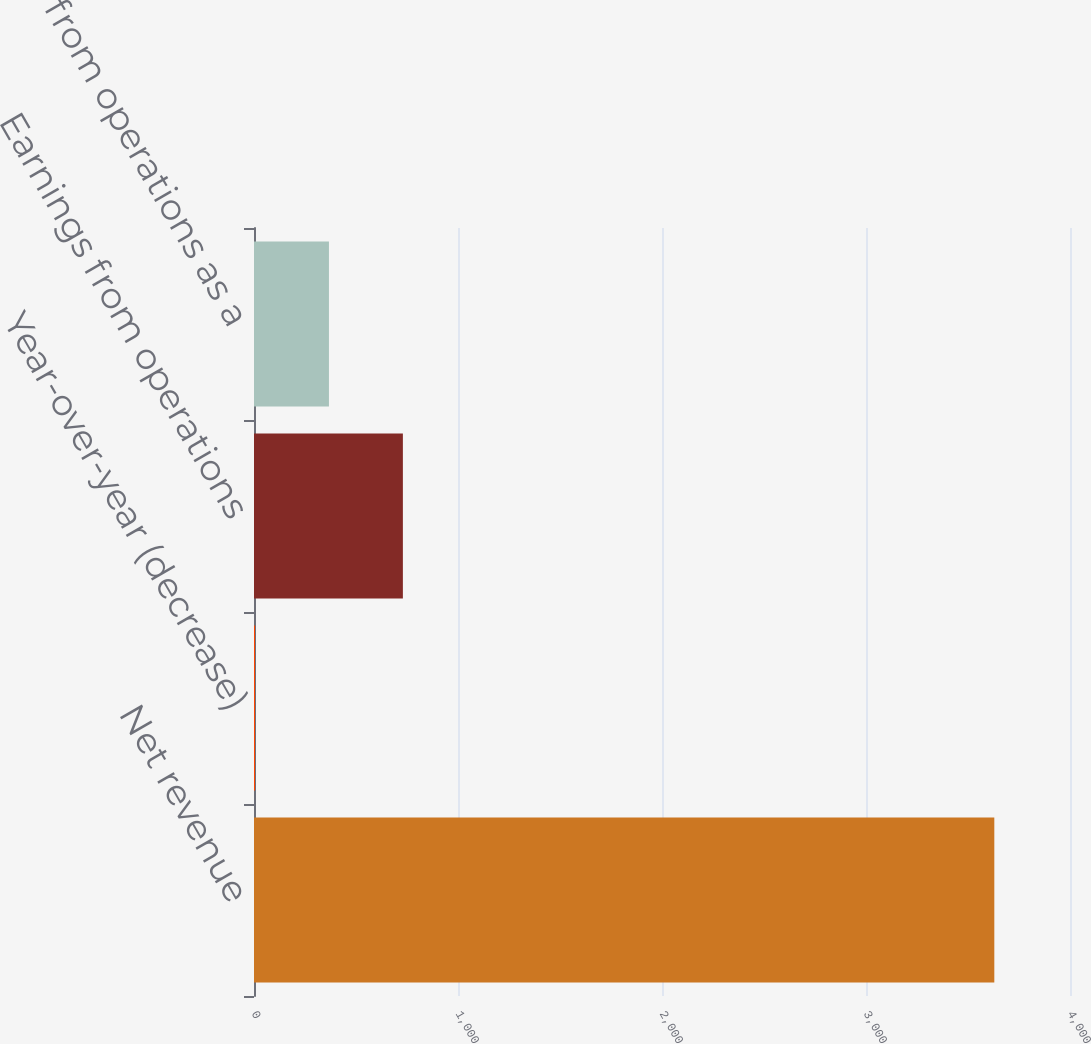Convert chart to OTSL. <chart><loc_0><loc_0><loc_500><loc_500><bar_chart><fcel>Net revenue<fcel>Year-over-year (decrease)<fcel>Earnings from operations<fcel>Earnings from operations as a<nl><fcel>3629<fcel>5<fcel>729.8<fcel>367.4<nl></chart> 